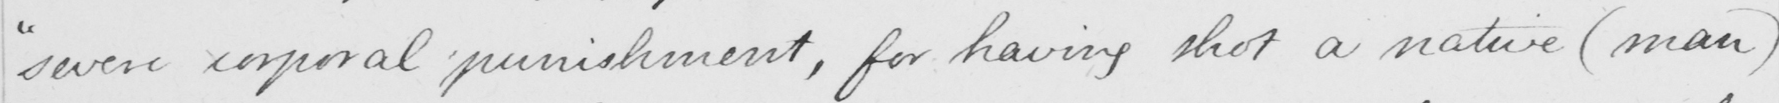Transcribe the text shown in this historical manuscript line. " severe corporal punishment , for having shot a native  ( man ) 